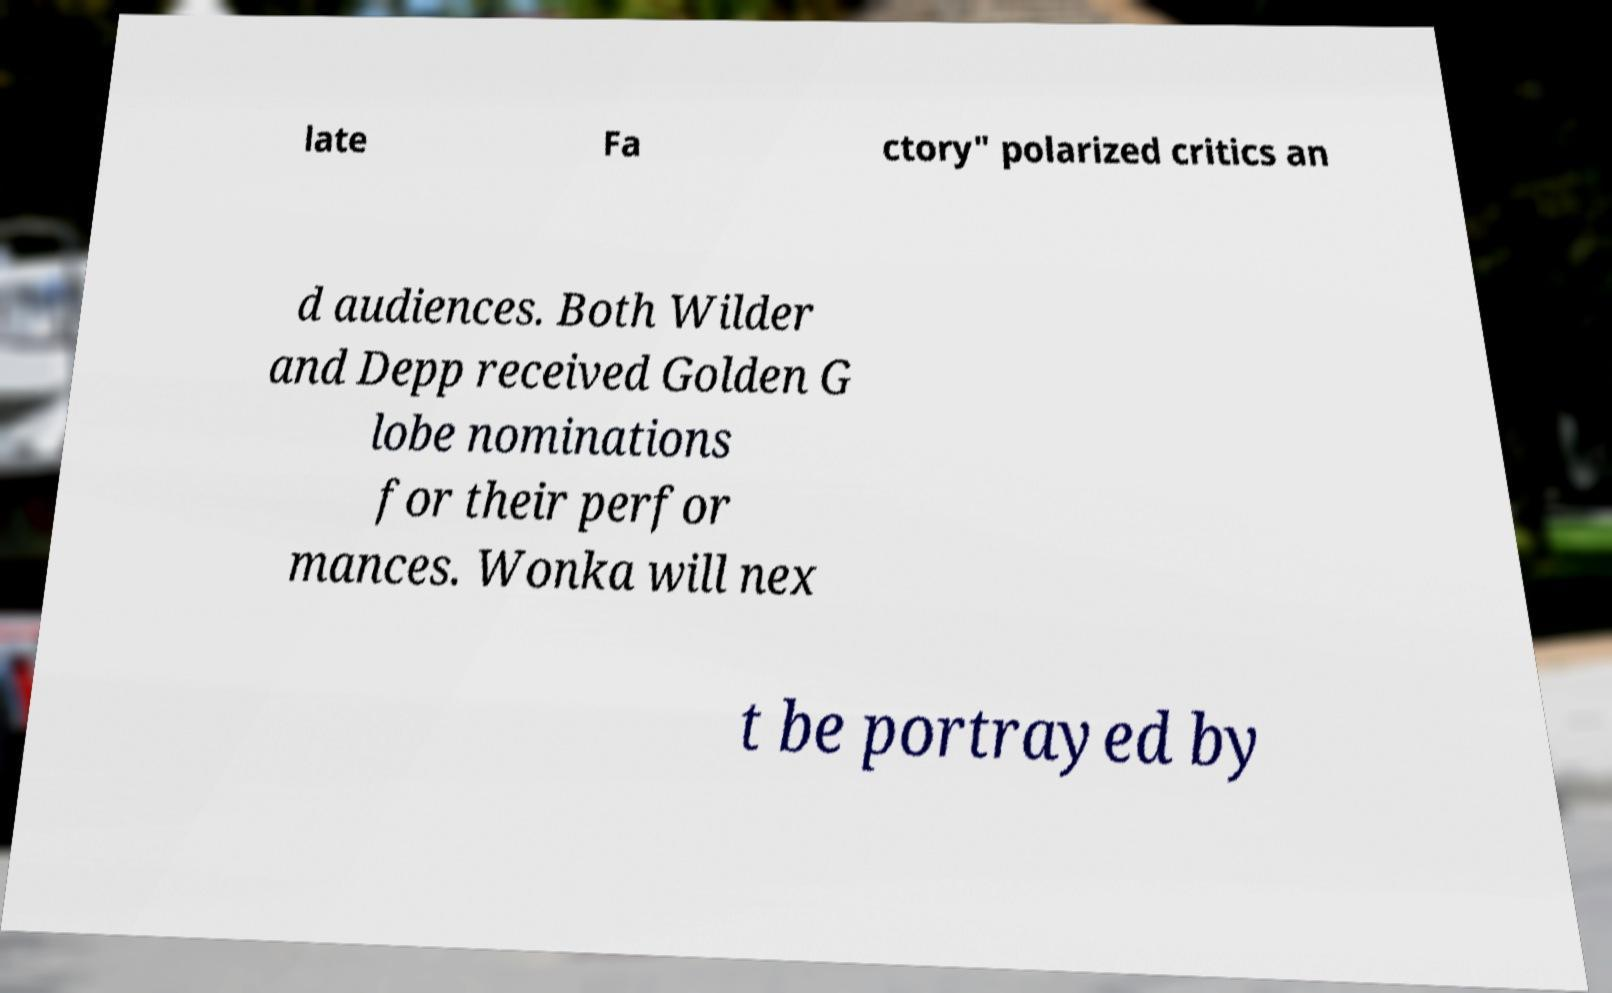I need the written content from this picture converted into text. Can you do that? late Fa ctory" polarized critics an d audiences. Both Wilder and Depp received Golden G lobe nominations for their perfor mances. Wonka will nex t be portrayed by 